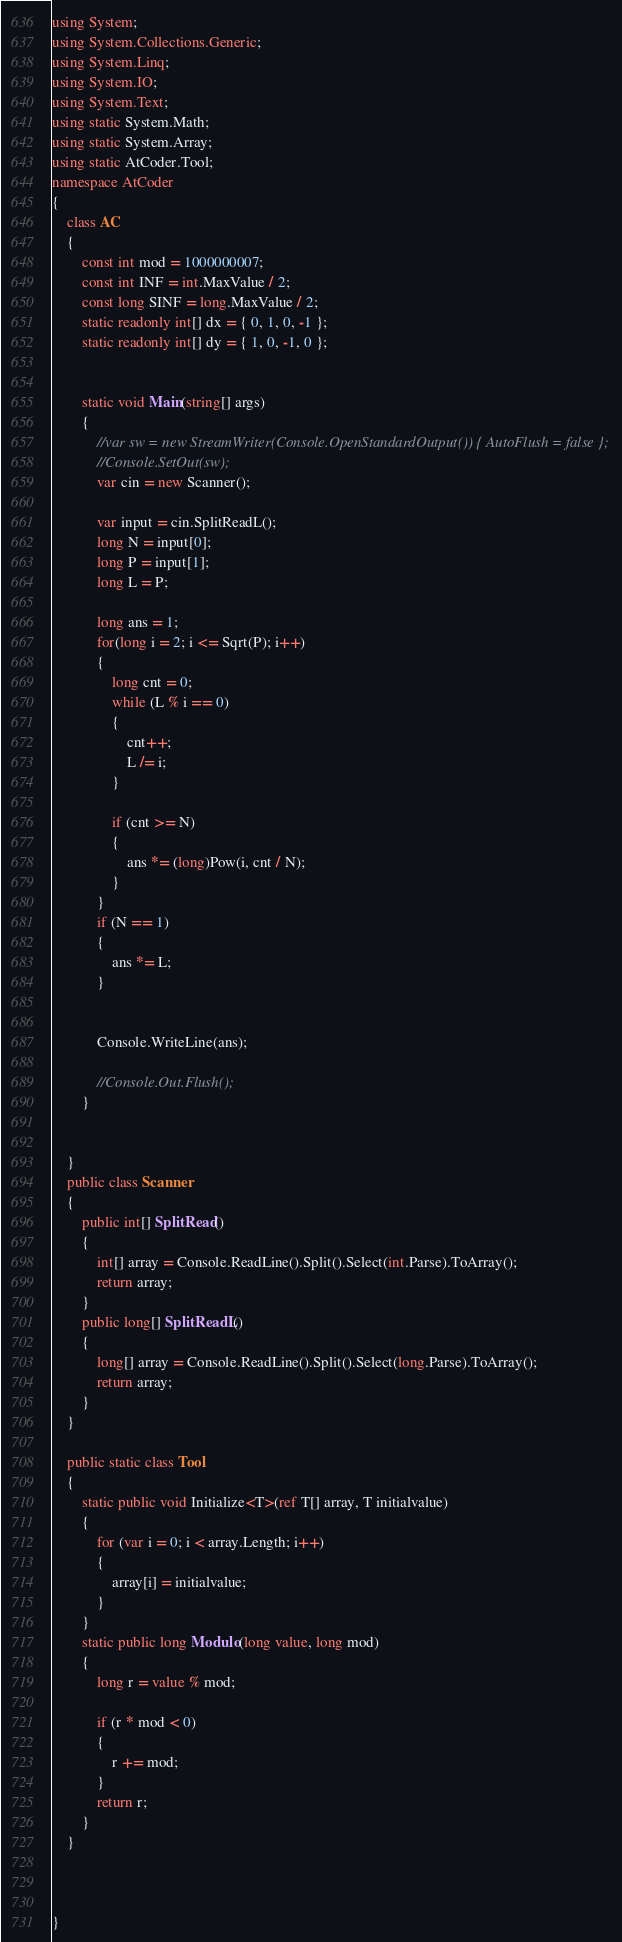Convert code to text. <code><loc_0><loc_0><loc_500><loc_500><_C#_>using System;
using System.Collections.Generic;
using System.Linq;
using System.IO;
using System.Text;
using static System.Math;
using static System.Array;
using static AtCoder.Tool;
namespace AtCoder
{
    class AC
    {
        const int mod = 1000000007;
        const int INF = int.MaxValue / 2;
        const long SINF = long.MaxValue / 2;
        static readonly int[] dx = { 0, 1, 0, -1 };
        static readonly int[] dy = { 1, 0, -1, 0 };
        

        static void Main(string[] args)
        {
            //var sw = new StreamWriter(Console.OpenStandardOutput()) { AutoFlush = false };
            //Console.SetOut(sw);
            var cin = new Scanner();

            var input = cin.SplitReadL();
            long N = input[0];
            long P = input[1];
            long L = P;

            long ans = 1;
            for(long i = 2; i <= Sqrt(P); i++)
            {
                long cnt = 0;
                while (L % i == 0)
                {
                    cnt++;
                    L /= i;
                }

                if (cnt >= N)
                {
                    ans *= (long)Pow(i, cnt / N);
                }
            }
            if (N == 1)
            {
                ans *= L;
            }
            

            Console.WriteLine(ans);

            //Console.Out.Flush();
        }
        
        
    }
    public class Scanner
    {
        public int[] SplitRead()
        {
            int[] array = Console.ReadLine().Split().Select(int.Parse).ToArray();
            return array;
        }
        public long[] SplitReadL()
        {
            long[] array = Console.ReadLine().Split().Select(long.Parse).ToArray();
            return array;
        }
    }

    public static class Tool
    {
        static public void Initialize<T>(ref T[] array, T initialvalue)
        {
            for (var i = 0; i < array.Length; i++)
            {
                array[i] = initialvalue;
            }
        }
        static public long Modulo(long value, long mod)
        {
            long r = value % mod;

            if (r * mod < 0)
            {
                r += mod;
            }
            return r;
        }
    }

    

}
</code> 